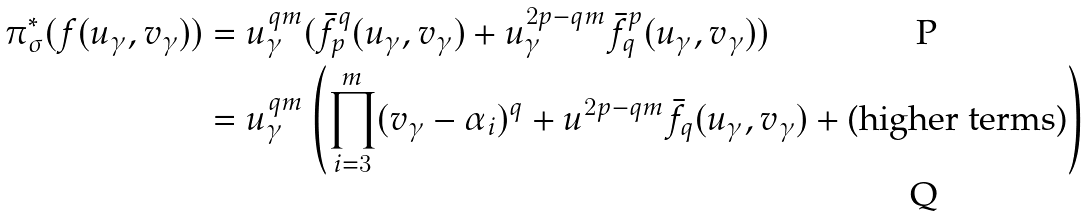Convert formula to latex. <formula><loc_0><loc_0><loc_500><loc_500>\pi _ { \sigma } ^ { * } ( f ( u _ { \gamma } , v _ { \gamma } ) ) & = u _ { \gamma } ^ { q m } ( \bar { f } _ { p } ^ { q } ( u _ { \gamma } , v _ { \gamma } ) + u _ { \gamma } ^ { 2 p - q m } \bar { f } _ { q } ^ { p } ( u _ { \gamma } , v _ { \gamma } ) ) \\ & = u _ { \gamma } ^ { q m } \left ( \prod _ { i = 3 } ^ { m } ( v _ { \gamma } - \alpha _ { i } ) ^ { q } + u ^ { 2 p - q m } \bar { f } _ { q } ( u _ { \gamma } , v _ { \gamma } ) + \text {(higher terms)} \right )</formula> 